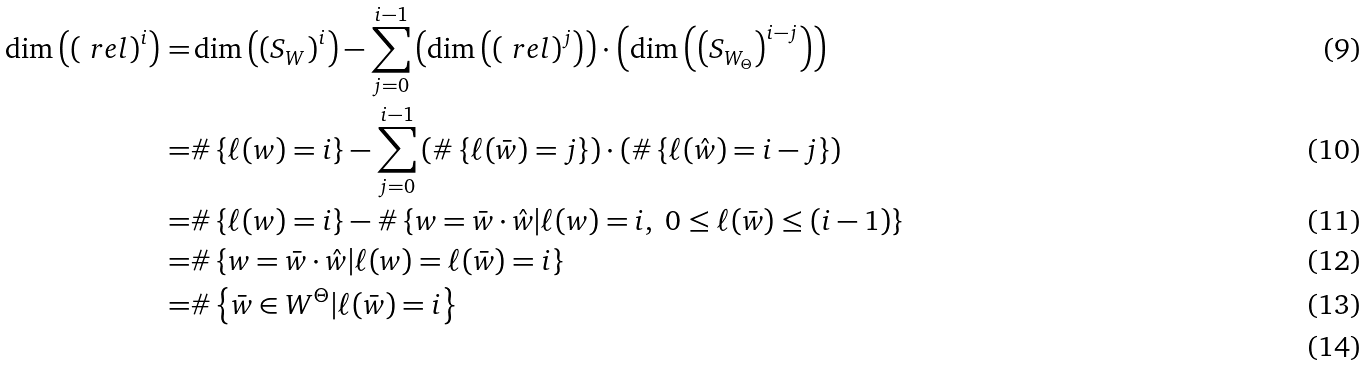Convert formula to latex. <formula><loc_0><loc_0><loc_500><loc_500>\dim \left ( \left ( \ r e l \right ) ^ { i } \right ) = & \dim \left ( \left ( S _ { W } \right ) ^ { i } \right ) - \sum _ { j = 0 } ^ { i - 1 } \left ( \dim \left ( \left ( \ r e l \right ) ^ { j } \right ) \right ) \cdot \left ( \dim \left ( \left ( S _ { W _ { \Theta } } \right ) ^ { i - j } \right ) \right ) \\ = & \# \left \{ \ell ( w ) = i \right \} - \sum _ { j = 0 } ^ { i - 1 } \left ( \# \left \{ \ell ( \bar { w } ) = j \right \} \right ) \cdot \left ( \# \left \{ \ell ( \hat { w } ) = i - j \right \} \right ) \\ = & \# \left \{ \ell ( w ) = i \right \} - \# \left \{ w = \bar { w } \cdot \hat { w } | \ell ( w ) = i , \ 0 \leq \ell ( \bar { w } ) \leq ( i - 1 ) \right \} \\ = & \# \left \{ w = \bar { w } \cdot \hat { w } | \ell ( w ) = \ell ( \bar { w } ) = i \right \} \\ = & \# \left \{ \bar { w } \in W ^ { \Theta } | \ell ( \bar { w } ) = i \right \} \\</formula> 